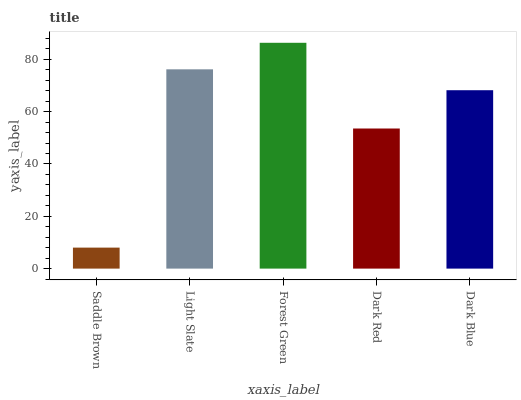Is Saddle Brown the minimum?
Answer yes or no. Yes. Is Forest Green the maximum?
Answer yes or no. Yes. Is Light Slate the minimum?
Answer yes or no. No. Is Light Slate the maximum?
Answer yes or no. No. Is Light Slate greater than Saddle Brown?
Answer yes or no. Yes. Is Saddle Brown less than Light Slate?
Answer yes or no. Yes. Is Saddle Brown greater than Light Slate?
Answer yes or no. No. Is Light Slate less than Saddle Brown?
Answer yes or no. No. Is Dark Blue the high median?
Answer yes or no. Yes. Is Dark Blue the low median?
Answer yes or no. Yes. Is Light Slate the high median?
Answer yes or no. No. Is Forest Green the low median?
Answer yes or no. No. 